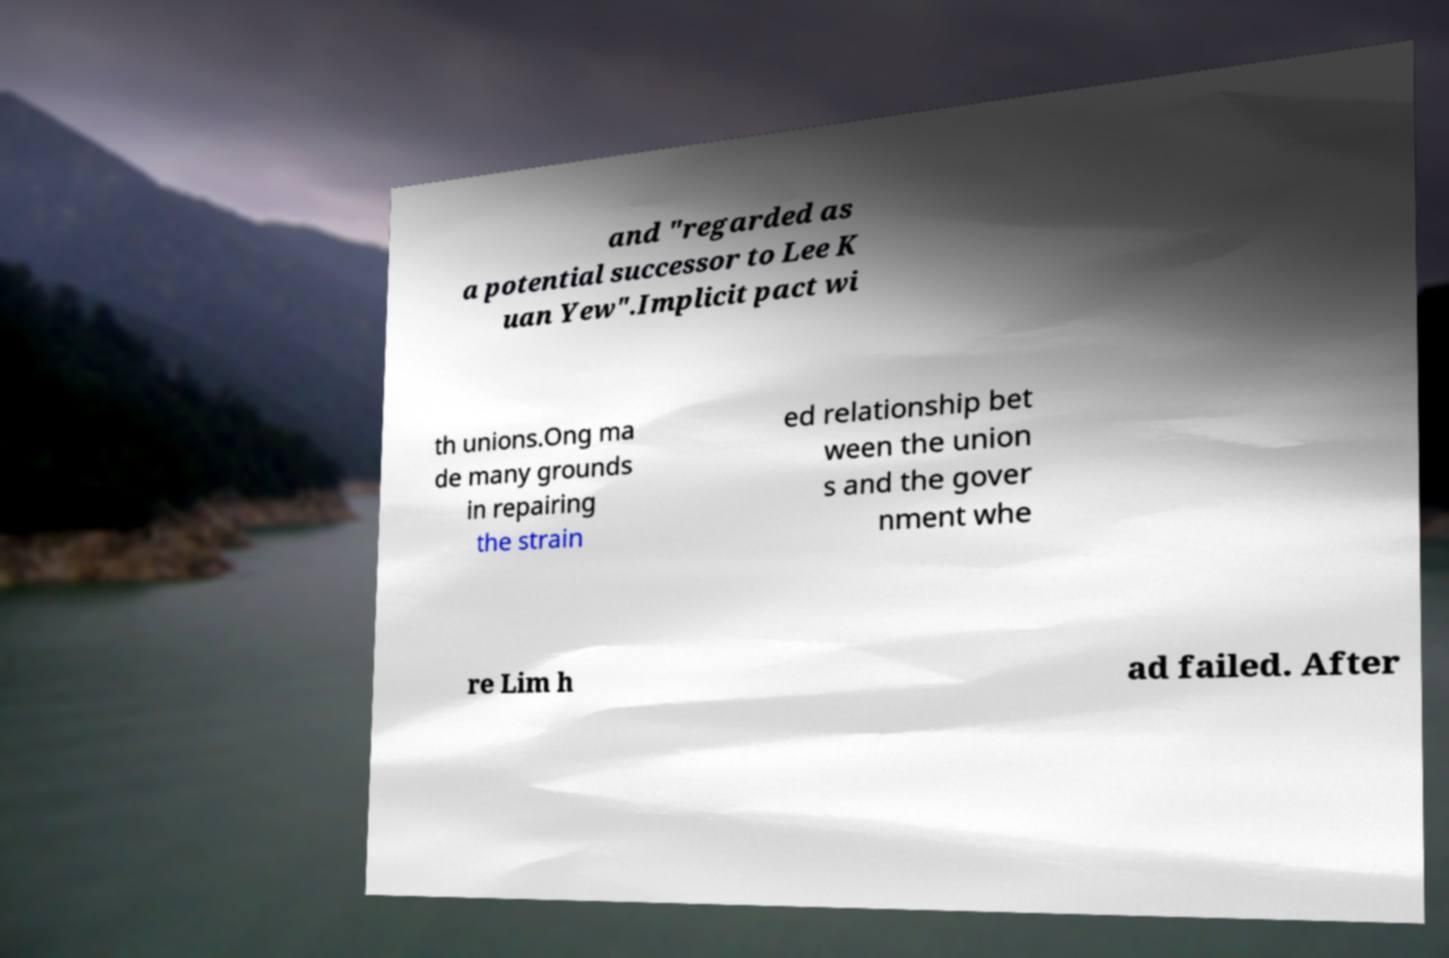Could you assist in decoding the text presented in this image and type it out clearly? and "regarded as a potential successor to Lee K uan Yew".Implicit pact wi th unions.Ong ma de many grounds in repairing the strain ed relationship bet ween the union s and the gover nment whe re Lim h ad failed. After 